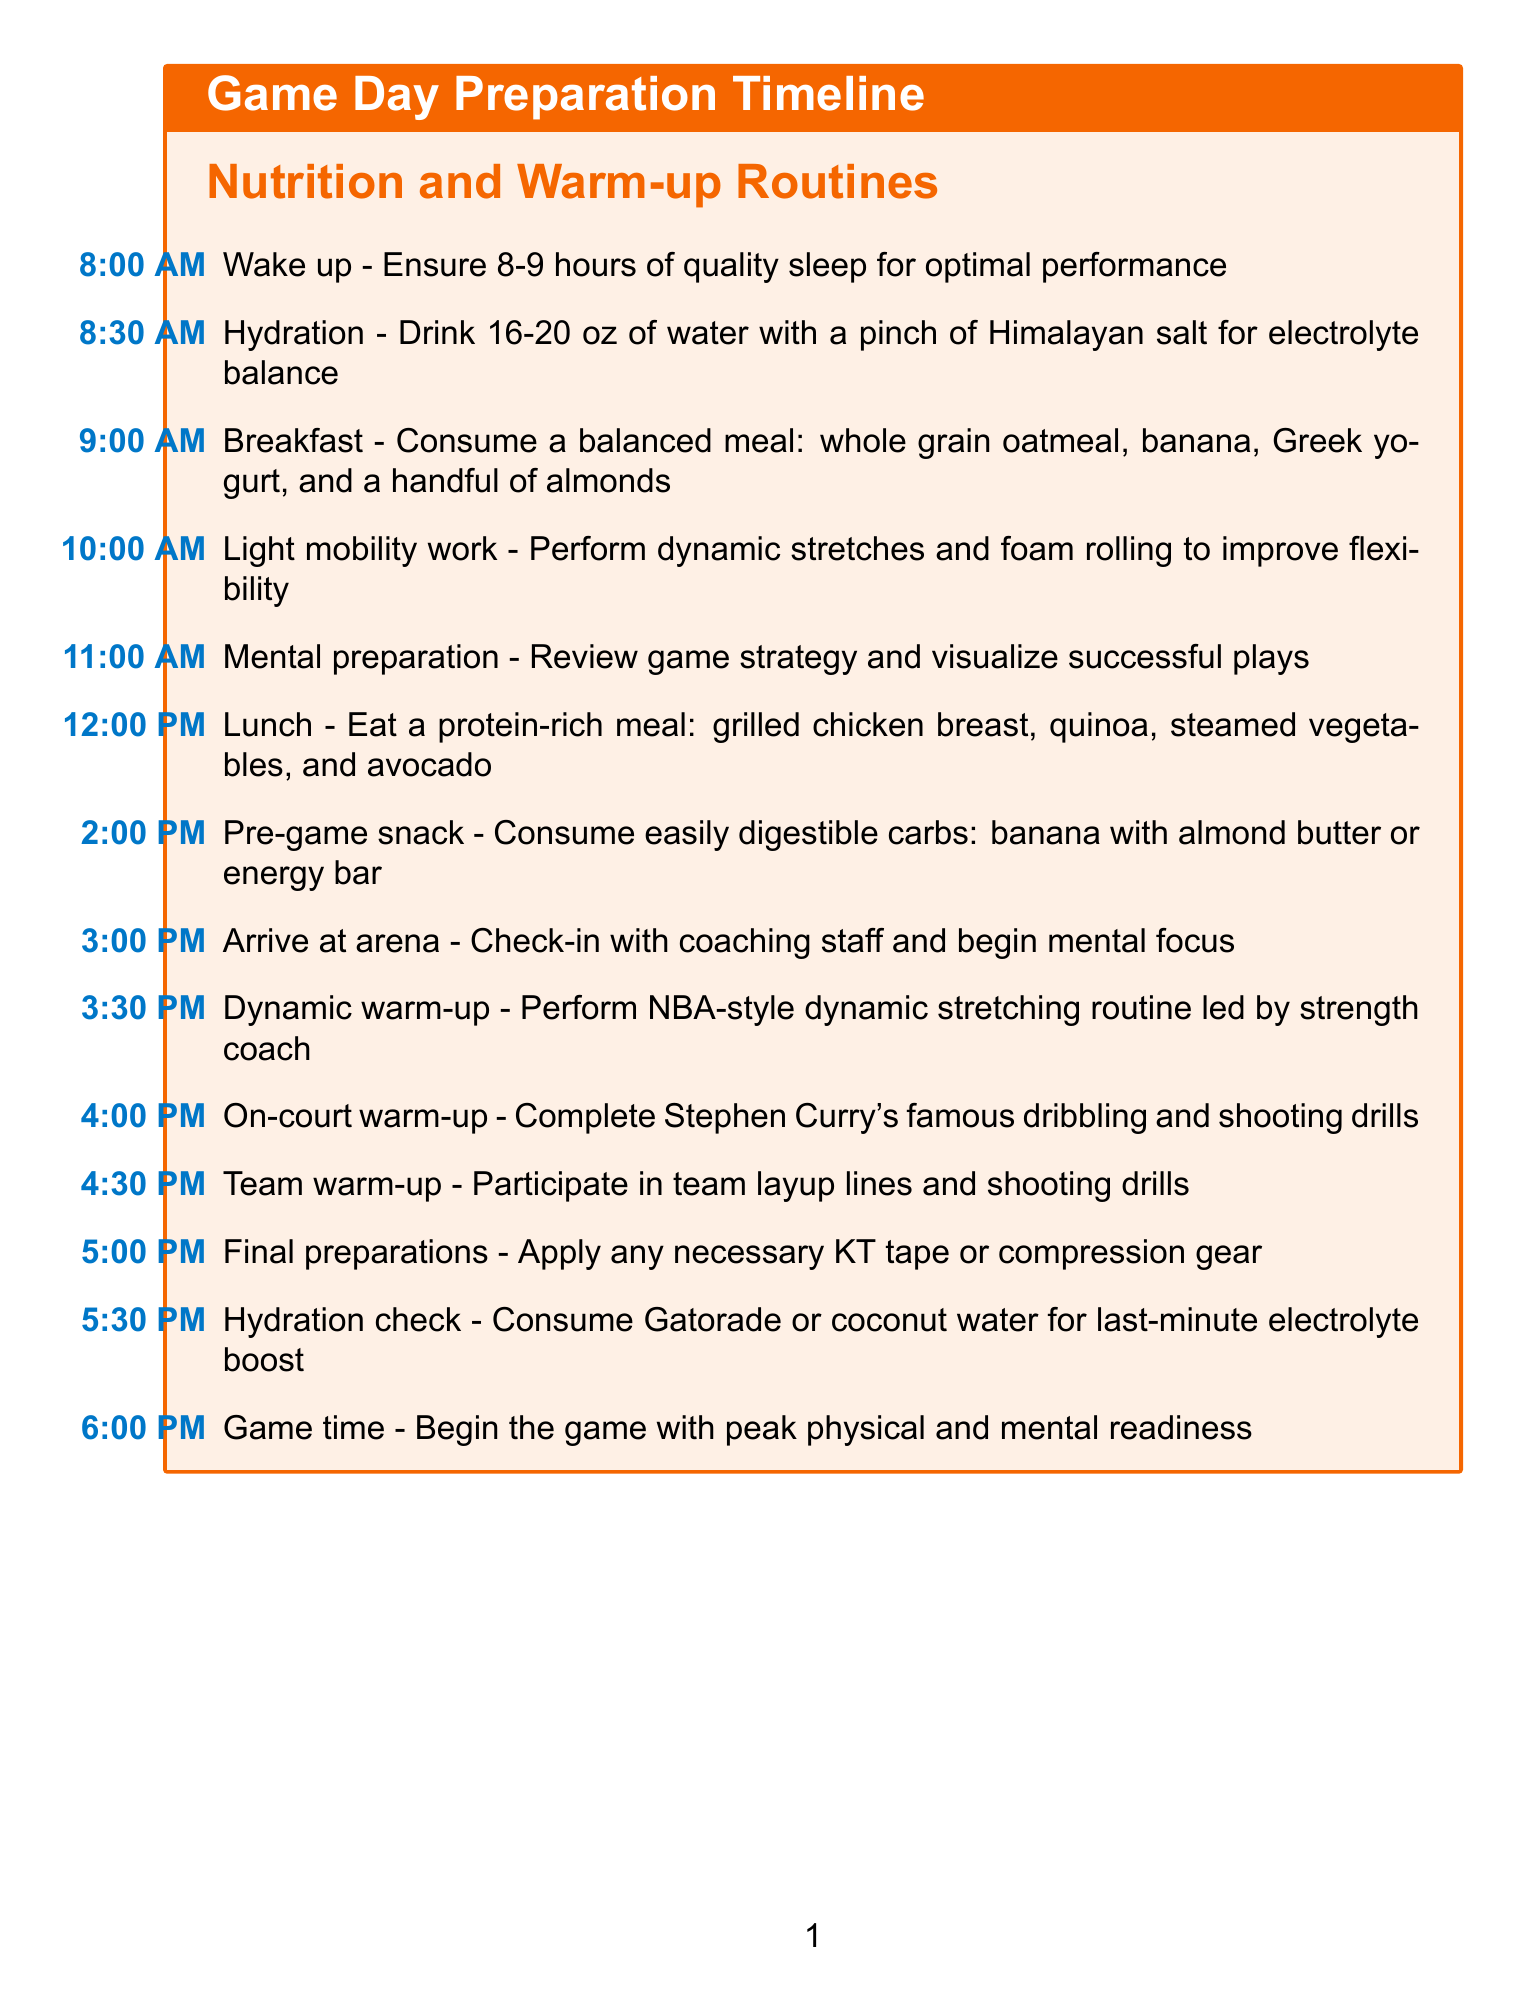What time should the player wake up? The player should wake up at 8:00 AM for optimal performance.
Answer: 8:00 AM What is included in the player's breakfast? The breakfast must be a balanced meal that includes whole grain oatmeal, banana, Greek yogurt, and almonds.
Answer: Whole grain oatmeal, banana, Greek yogurt, and a handful of almonds When is the pre-game snack scheduled? The pre-game snack is essential for energy and is scheduled at 2:00 PM.
Answer: 2:00 PM What activity takes place at 3:30 PM? The dynamic warm-up occurs at 3:30 PM and is led by the strength coach.
Answer: Dynamic warm-up What type of meal is consumed for lunch? Lunch consists of a protein-rich meal including grilled chicken, quinoa, steamed vegetables, and avocado.
Answer: Protein-rich meal How long before the game should the hydration check occur? The hydration check happens at 5:30 PM, which is 30 minutes before the game starts at 6:00 PM.
Answer: 30 minutes What is the focus of the mental preparation activity? The focus of the mental preparation is to review game strategy and visualize successful plays.
Answer: Game strategy and visualization What specific drills does the player perform during the on-court warm-up? The player completes Stephen Curry's famous dribbling and shooting drills during the on-court warm-up.
Answer: Stephen Curry's famous dribbling and shooting drills What is the overall goal of the activities listed on game day? The overall goal is to ensure the player achieves peak physical and mental readiness for the game.
Answer: Peak physical and mental readiness 